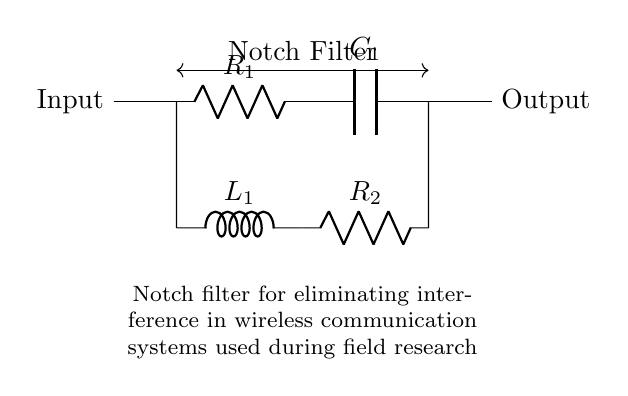What is the input connection point in the circuit? The input connection point is marked as the left side of the circuit diagram, indicated with the label "Input."
Answer: Input What component is labeled R1? R1 is the resistor located between the input and the capacitor in the upper part of the circuit.
Answer: Resistor How many components are in the lower branch of the circuit? The lower branch contains two components: an inductor and a resistor. They are labeled L1 and R2, respectively.
Answer: Two What type of filter is represented in the circuit? The circuit represents a notch filter, which is specifically designed to eliminate specific frequency interference by using both resistors and inductors or capacitors.
Answer: Notch Filter What is the function of the capacitor C1 in this circuit? Capacitor C1 works in conjunction with R1 to form part of the filtering process, helping to eliminate unwanted frequencies.
Answer: Filtering Why is the notch filter important for wireless communication? The notch filter is important for eliminating specific frequency interference, enhancing signal quality and reliability in wireless communications, especially during field research.
Answer: Eliminates interference 